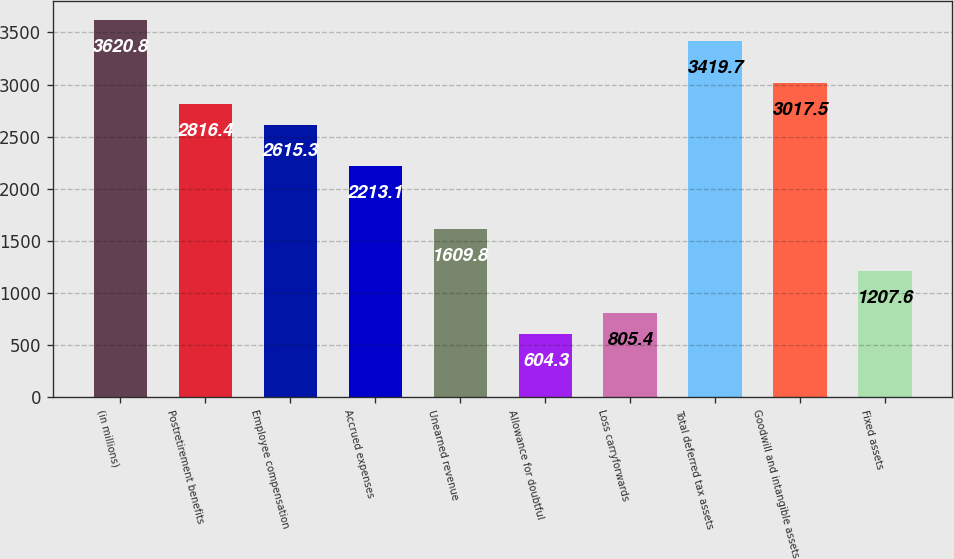Convert chart to OTSL. <chart><loc_0><loc_0><loc_500><loc_500><bar_chart><fcel>(in millions)<fcel>Postretirement benefits<fcel>Employee compensation<fcel>Accrued expenses<fcel>Unearned revenue<fcel>Allowance for doubtful<fcel>Loss carryforwards<fcel>Total deferred tax assets<fcel>Goodwill and intangible assets<fcel>Fixed assets<nl><fcel>3620.8<fcel>2816.4<fcel>2615.3<fcel>2213.1<fcel>1609.8<fcel>604.3<fcel>805.4<fcel>3419.7<fcel>3017.5<fcel>1207.6<nl></chart> 